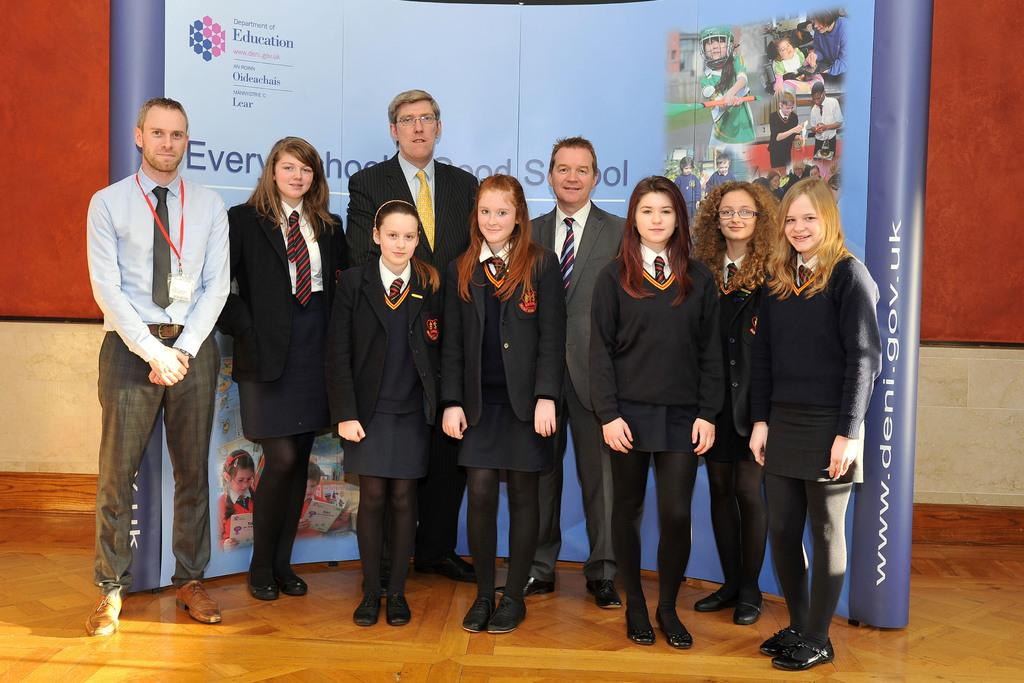What are the persons in the image doing? The persons in the image are standing on the floor. Where are the persons located in relation to the hoarding? The persons are near a hoarding. What can be seen in the background of the image? There is a wall and an unspecified object in the background of the image. What decision did the persons make in the image? There is no indication in the image that the persons made any decisions. What hope do the persons have in the image? There is no indication in the image of any hopes or aspirations of the persons. 